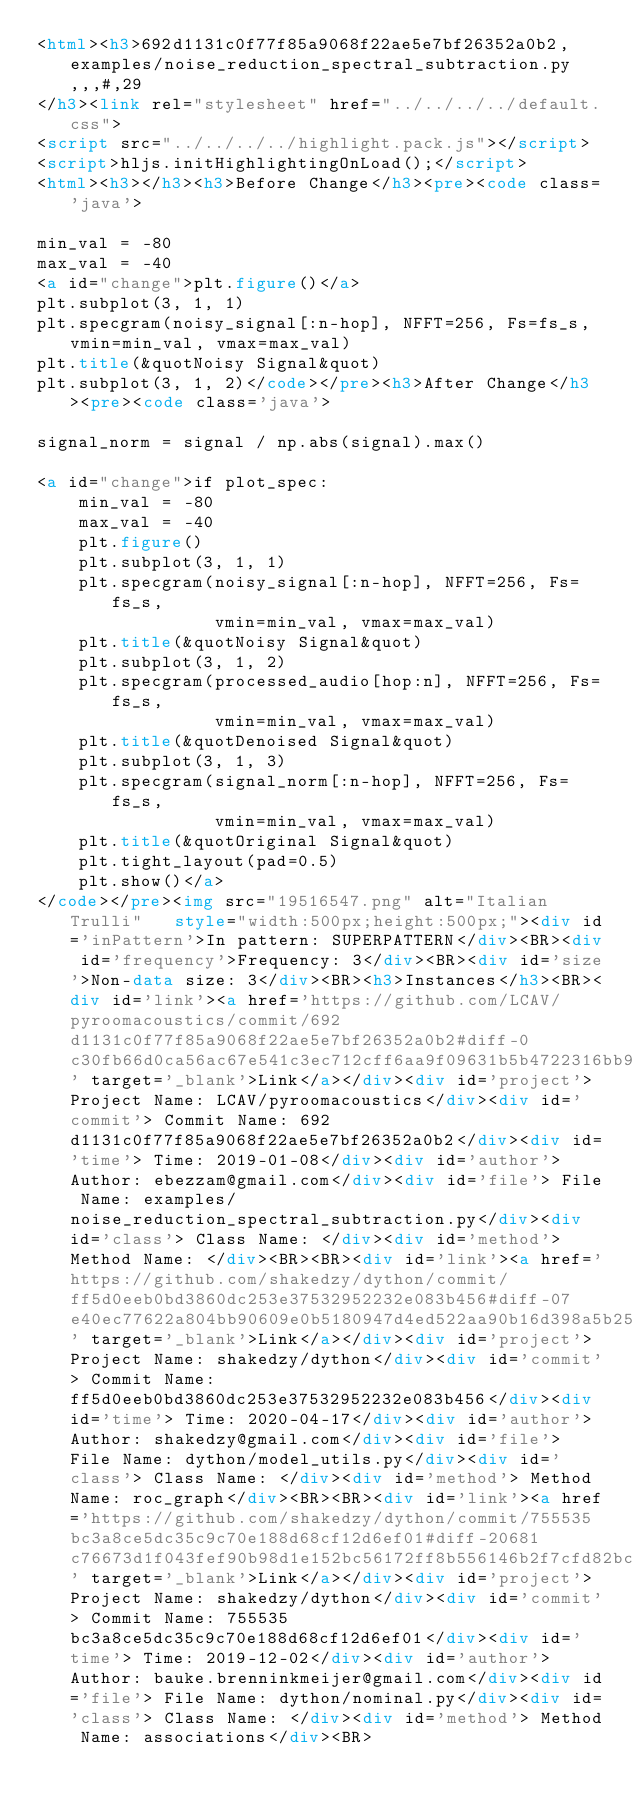Convert code to text. <code><loc_0><loc_0><loc_500><loc_500><_HTML_><html><h3>692d1131c0f77f85a9068f22ae5e7bf26352a0b2,examples/noise_reduction_spectral_subtraction.py,,,#,29
</h3><link rel="stylesheet" href="../../../../default.css">
<script src="../../../../highlight.pack.js"></script> 
<script>hljs.initHighlightingOnLoad();</script>
<html><h3></h3><h3>Before Change</h3><pre><code class='java'>

min_val = -80
max_val = -40
<a id="change">plt.figure()</a>
plt.subplot(3, 1, 1)
plt.specgram(noisy_signal[:n-hop], NFFT=256, Fs=fs_s, vmin=min_val, vmax=max_val)
plt.title(&quotNoisy Signal&quot)
plt.subplot(3, 1, 2)</code></pre><h3>After Change</h3><pre><code class='java'>

signal_norm = signal / np.abs(signal).max()

<a id="change">if plot_spec:
    min_val = -80
    max_val = -40
    plt.figure()
    plt.subplot(3, 1, 1)
    plt.specgram(noisy_signal[:n-hop], NFFT=256, Fs=fs_s,
                 vmin=min_val, vmax=max_val)
    plt.title(&quotNoisy Signal&quot)
    plt.subplot(3, 1, 2)
    plt.specgram(processed_audio[hop:n], NFFT=256, Fs=fs_s,
                 vmin=min_val, vmax=max_val)
    plt.title(&quotDenoised Signal&quot)
    plt.subplot(3, 1, 3)
    plt.specgram(signal_norm[:n-hop], NFFT=256, Fs=fs_s,
                 vmin=min_val, vmax=max_val)
    plt.title(&quotOriginal Signal&quot)
    plt.tight_layout(pad=0.5)
    plt.show()</a>
</code></pre><img src="19516547.png" alt="Italian Trulli"   style="width:500px;height:500px;"><div id='inPattern'>In pattern: SUPERPATTERN</div><BR><div id='frequency'>Frequency: 3</div><BR><div id='size'>Non-data size: 3</div><BR><h3>Instances</h3><BR><div id='link'><a href='https://github.com/LCAV/pyroomacoustics/commit/692d1131c0f77f85a9068f22ae5e7bf26352a0b2#diff-0c30fb66d0ca56ac67e541c3ec712cff6aa9f09631b5b4722316bb9524ae22b7L30' target='_blank'>Link</a></div><div id='project'> Project Name: LCAV/pyroomacoustics</div><div id='commit'> Commit Name: 692d1131c0f77f85a9068f22ae5e7bf26352a0b2</div><div id='time'> Time: 2019-01-08</div><div id='author'> Author: ebezzam@gmail.com</div><div id='file'> File Name: examples/noise_reduction_spectral_subtraction.py</div><div id='class'> Class Name: </div><div id='method'> Method Name: </div><BR><BR><div id='link'><a href='https://github.com/shakedzy/dython/commit/ff5d0eeb0bd3860dc253e37532952232e083b456#diff-07e40ec77622a804bb90609e0b5180947d4ed522aa90b16d398a5b255720b838L194' target='_blank'>Link</a></div><div id='project'> Project Name: shakedzy/dython</div><div id='commit'> Commit Name: ff5d0eeb0bd3860dc253e37532952232e083b456</div><div id='time'> Time: 2020-04-17</div><div id='author'> Author: shakedzy@gmail.com</div><div id='file'> File Name: dython/model_utils.py</div><div id='class'> Class Name: </div><div id='method'> Method Name: roc_graph</div><BR><BR><div id='link'><a href='https://github.com/shakedzy/dython/commit/755535bc3a8ce5dc35c9c70e188d68cf12d6ef01#diff-20681c76673d1f043fef90b98d1e152bc56172ff8b556146b2f7cfd82bc0c7f5L260' target='_blank'>Link</a></div><div id='project'> Project Name: shakedzy/dython</div><div id='commit'> Commit Name: 755535bc3a8ce5dc35c9c70e188d68cf12d6ef01</div><div id='time'> Time: 2019-12-02</div><div id='author'> Author: bauke.brenninkmeijer@gmail.com</div><div id='file'> File Name: dython/nominal.py</div><div id='class'> Class Name: </div><div id='method'> Method Name: associations</div><BR></code> 